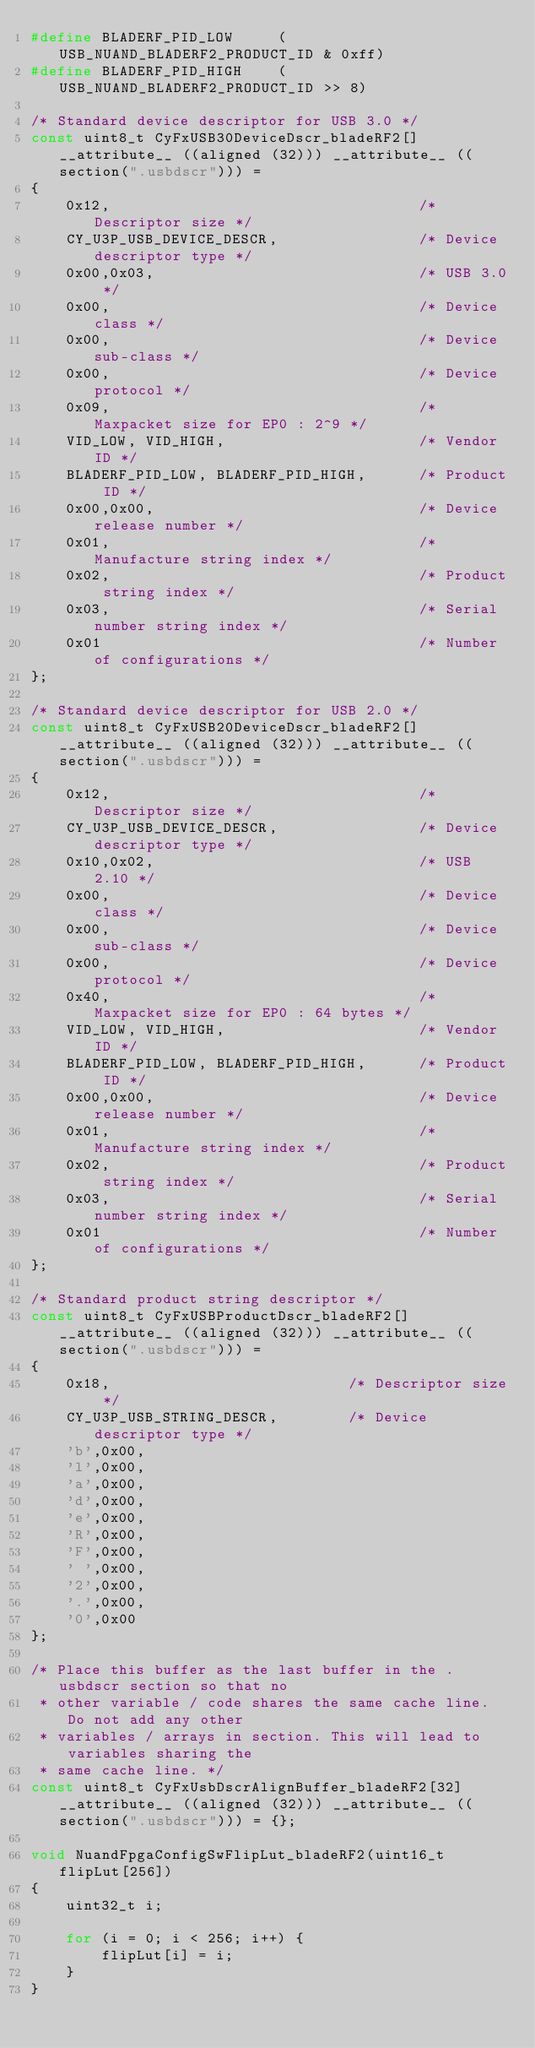Convert code to text. <code><loc_0><loc_0><loc_500><loc_500><_C_>#define BLADERF_PID_LOW     (USB_NUAND_BLADERF2_PRODUCT_ID & 0xff)
#define BLADERF_PID_HIGH    (USB_NUAND_BLADERF2_PRODUCT_ID >> 8)

/* Standard device descriptor for USB 3.0 */
const uint8_t CyFxUSB30DeviceDscr_bladeRF2[] __attribute__ ((aligned (32))) __attribute__ ((section(".usbdscr"))) =
{
    0x12,                                   /* Descriptor size */
    CY_U3P_USB_DEVICE_DESCR,                /* Device descriptor type */
    0x00,0x03,                              /* USB 3.0 */
    0x00,                                   /* Device class */
    0x00,                                   /* Device sub-class */
    0x00,                                   /* Device protocol */
    0x09,                                   /* Maxpacket size for EP0 : 2^9 */
    VID_LOW, VID_HIGH,                      /* Vendor ID */
    BLADERF_PID_LOW, BLADERF_PID_HIGH,      /* Product ID */
    0x00,0x00,                              /* Device release number */
    0x01,                                   /* Manufacture string index */
    0x02,                                   /* Product string index */
    0x03,                                   /* Serial number string index */
    0x01                                    /* Number of configurations */
};

/* Standard device descriptor for USB 2.0 */
const uint8_t CyFxUSB20DeviceDscr_bladeRF2[] __attribute__ ((aligned (32))) __attribute__ ((section(".usbdscr"))) =
{
    0x12,                                   /* Descriptor size */
    CY_U3P_USB_DEVICE_DESCR,                /* Device descriptor type */
    0x10,0x02,                              /* USB 2.10 */
    0x00,                                   /* Device class */
    0x00,                                   /* Device sub-class */
    0x00,                                   /* Device protocol */
    0x40,                                   /* Maxpacket size for EP0 : 64 bytes */
    VID_LOW, VID_HIGH,                      /* Vendor ID */
    BLADERF_PID_LOW, BLADERF_PID_HIGH,      /* Product ID */
    0x00,0x00,                              /* Device release number */
    0x01,                                   /* Manufacture string index */
    0x02,                                   /* Product string index */
    0x03,                                   /* Serial number string index */
    0x01                                    /* Number of configurations */
};

/* Standard product string descriptor */
const uint8_t CyFxUSBProductDscr_bladeRF2[] __attribute__ ((aligned (32))) __attribute__ ((section(".usbdscr"))) =
{
    0x18,                           /* Descriptor size */
    CY_U3P_USB_STRING_DESCR,        /* Device descriptor type */
    'b',0x00,
    'l',0x00,
    'a',0x00,
    'd',0x00,
    'e',0x00,
    'R',0x00,
    'F',0x00,
    ' ',0x00,
    '2',0x00,
    '.',0x00,
    '0',0x00
};

/* Place this buffer as the last buffer in the .usbdscr section so that no
 * other variable / code shares the same cache line. Do not add any other
 * variables / arrays in section. This will lead to variables sharing the
 * same cache line. */
const uint8_t CyFxUsbDscrAlignBuffer_bladeRF2[32] __attribute__ ((aligned (32))) __attribute__ ((section(".usbdscr"))) = {};

void NuandFpgaConfigSwFlipLut_bladeRF2(uint16_t flipLut[256])
{
    uint32_t i;

    for (i = 0; i < 256; i++) {
        flipLut[i] = i;
    }
}
</code> 